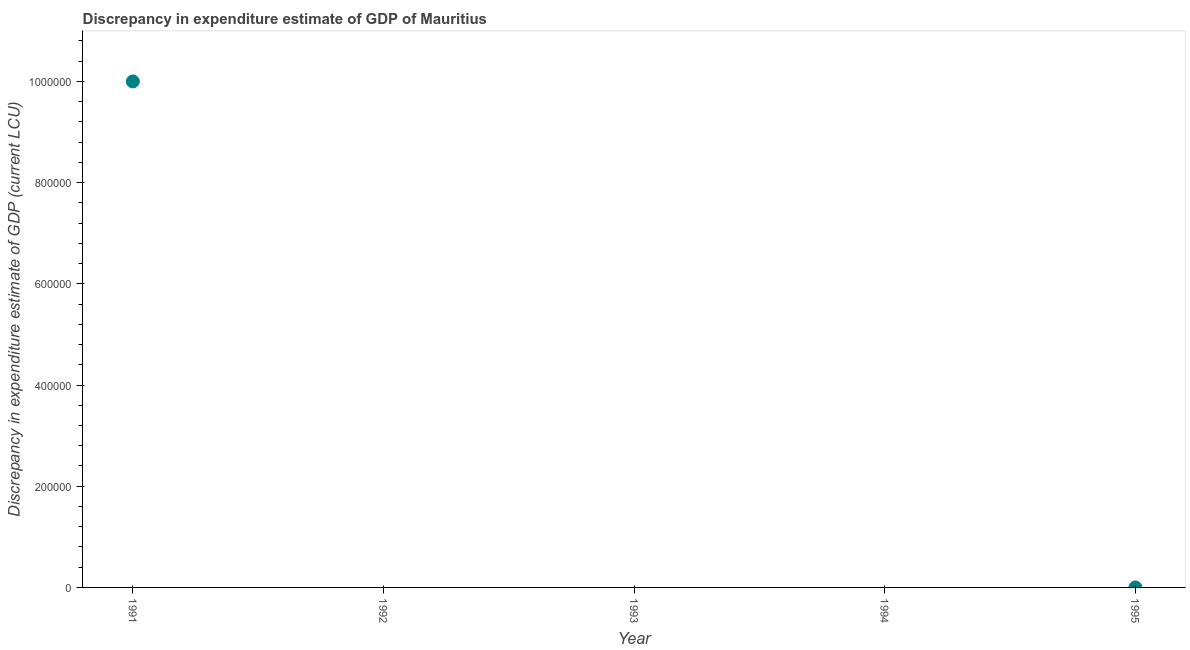What is the discrepancy in expenditure estimate of gdp in 1992?
Make the answer very short. 0. Across all years, what is the maximum discrepancy in expenditure estimate of gdp?
Your answer should be compact. 1.00e+06. Across all years, what is the minimum discrepancy in expenditure estimate of gdp?
Keep it short and to the point. 0. In which year was the discrepancy in expenditure estimate of gdp maximum?
Provide a succinct answer. 1991. What is the sum of the discrepancy in expenditure estimate of gdp?
Give a very brief answer. 1.00e+06. What is the average discrepancy in expenditure estimate of gdp per year?
Provide a short and direct response. 2.00e+05. In how many years, is the discrepancy in expenditure estimate of gdp greater than 160000 LCU?
Provide a short and direct response. 1. What is the ratio of the discrepancy in expenditure estimate of gdp in 1991 to that in 1995?
Provide a short and direct response. 1.02e+1. Is the difference between the discrepancy in expenditure estimate of gdp in 1991 and 1995 greater than the difference between any two years?
Offer a terse response. No. What is the difference between the highest and the lowest discrepancy in expenditure estimate of gdp?
Make the answer very short. 1.00e+06. Are the values on the major ticks of Y-axis written in scientific E-notation?
Make the answer very short. No. What is the title of the graph?
Your answer should be compact. Discrepancy in expenditure estimate of GDP of Mauritius. What is the label or title of the Y-axis?
Offer a very short reply. Discrepancy in expenditure estimate of GDP (current LCU). What is the Discrepancy in expenditure estimate of GDP (current LCU) in 1991?
Offer a terse response. 1.00e+06. What is the Discrepancy in expenditure estimate of GDP (current LCU) in 1994?
Ensure brevity in your answer.  0. What is the Discrepancy in expenditure estimate of GDP (current LCU) in 1995?
Your answer should be very brief. 9.78e-5. What is the difference between the Discrepancy in expenditure estimate of GDP (current LCU) in 1991 and 1995?
Give a very brief answer. 1.00e+06. What is the ratio of the Discrepancy in expenditure estimate of GDP (current LCU) in 1991 to that in 1995?
Ensure brevity in your answer.  1.02e+1. 